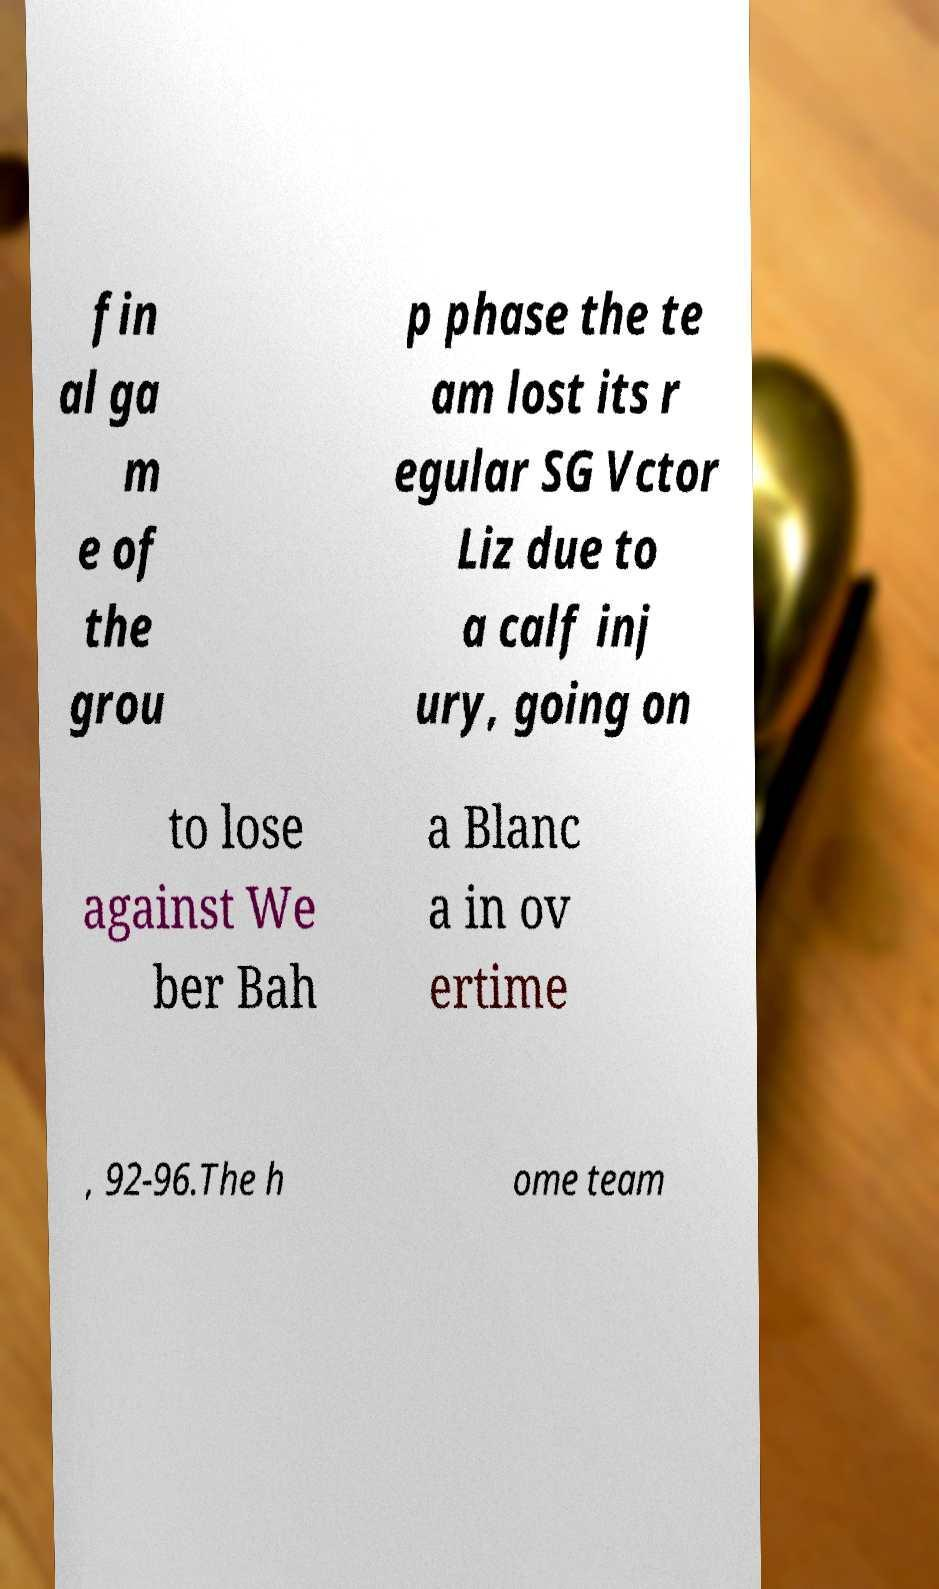Can you accurately transcribe the text from the provided image for me? fin al ga m e of the grou p phase the te am lost its r egular SG Vctor Liz due to a calf inj ury, going on to lose against We ber Bah a Blanc a in ov ertime , 92-96.The h ome team 